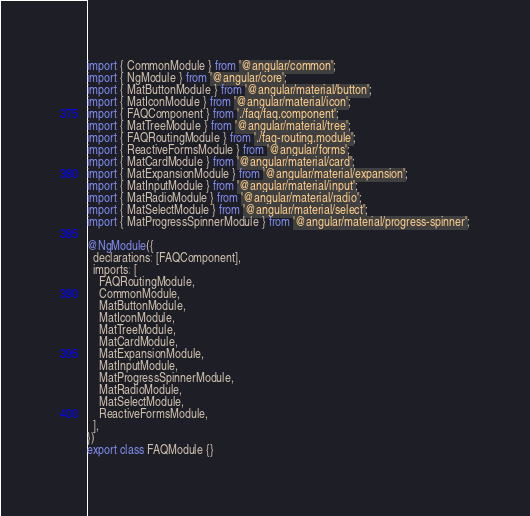<code> <loc_0><loc_0><loc_500><loc_500><_TypeScript_>import { CommonModule } from '@angular/common';
import { NgModule } from '@angular/core';
import { MatButtonModule } from '@angular/material/button';
import { MatIconModule } from '@angular/material/icon';
import { FAQComponent } from './faq/faq.component';
import { MatTreeModule } from '@angular/material/tree';
import { FAQRoutingModule } from './faq-routing.module';
import { ReactiveFormsModule } from '@angular/forms';
import { MatCardModule } from '@angular/material/card';
import { MatExpansionModule } from '@angular/material/expansion';
import { MatInputModule } from '@angular/material/input';
import { MatRadioModule } from '@angular/material/radio';
import { MatSelectModule } from '@angular/material/select';
import { MatProgressSpinnerModule } from '@angular/material/progress-spinner';

@NgModule({
  declarations: [FAQComponent],
  imports: [
    FAQRoutingModule,
    CommonModule,
    MatButtonModule,
    MatIconModule,
    MatTreeModule,
    MatCardModule,
    MatExpansionModule,
    MatInputModule,
    MatProgressSpinnerModule,
    MatRadioModule,
    MatSelectModule,
    ReactiveFormsModule,
  ],
})
export class FAQModule {}
</code> 